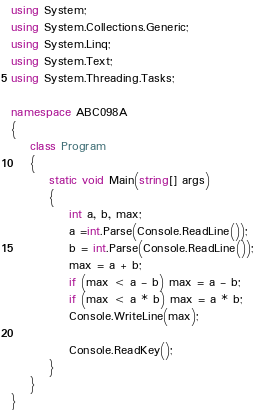Convert code to text. <code><loc_0><loc_0><loc_500><loc_500><_C#_>using System;
using System.Collections.Generic;
using System.Linq;
using System.Text;
using System.Threading.Tasks;

namespace ABC098A
{
    class Program
    {
        static void Main(string[] args)
        {
            int a, b, max;
            a =int.Parse(Console.ReadLine());
            b = int.Parse(Console.ReadLine());
            max = a + b;
            if (max < a - b) max = a - b;
            if (max < a * b) max = a * b;
            Console.WriteLine(max);

            Console.ReadKey();
        }
    }
}
</code> 